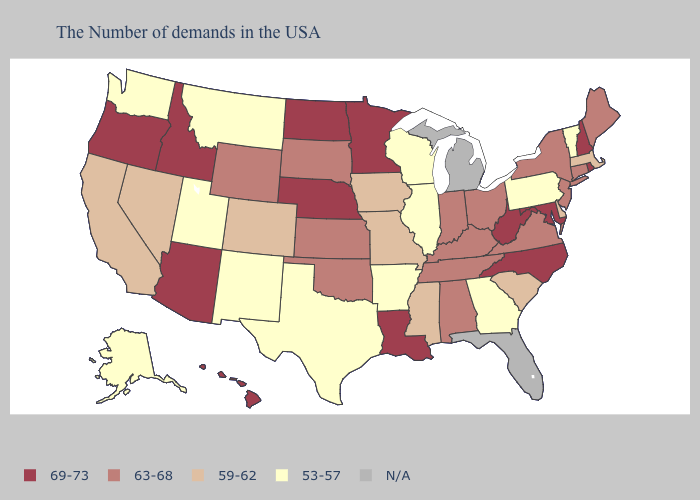Among the states that border Oklahoma , does Texas have the lowest value?
Write a very short answer. Yes. Which states hav the highest value in the West?
Write a very short answer. Arizona, Idaho, Oregon, Hawaii. Does New Mexico have the lowest value in the West?
Give a very brief answer. Yes. How many symbols are there in the legend?
Keep it brief. 5. What is the value of North Carolina?
Answer briefly. 69-73. What is the lowest value in states that border Montana?
Concise answer only. 63-68. What is the lowest value in the West?
Short answer required. 53-57. What is the value of Rhode Island?
Quick response, please. 69-73. Name the states that have a value in the range N/A?
Short answer required. Florida, Michigan. What is the value of Arizona?
Write a very short answer. 69-73. Which states have the lowest value in the USA?
Short answer required. Vermont, Pennsylvania, Georgia, Wisconsin, Illinois, Arkansas, Texas, New Mexico, Utah, Montana, Washington, Alaska. Does Minnesota have the highest value in the MidWest?
Give a very brief answer. Yes. What is the value of Oregon?
Short answer required. 69-73. Which states hav the highest value in the Northeast?
Quick response, please. Rhode Island, New Hampshire. Does Texas have the lowest value in the USA?
Quick response, please. Yes. 